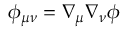Convert formula to latex. <formula><loc_0><loc_0><loc_500><loc_500>\phi _ { \mu \nu } = \nabla _ { \mu } \nabla _ { \nu } \phi</formula> 